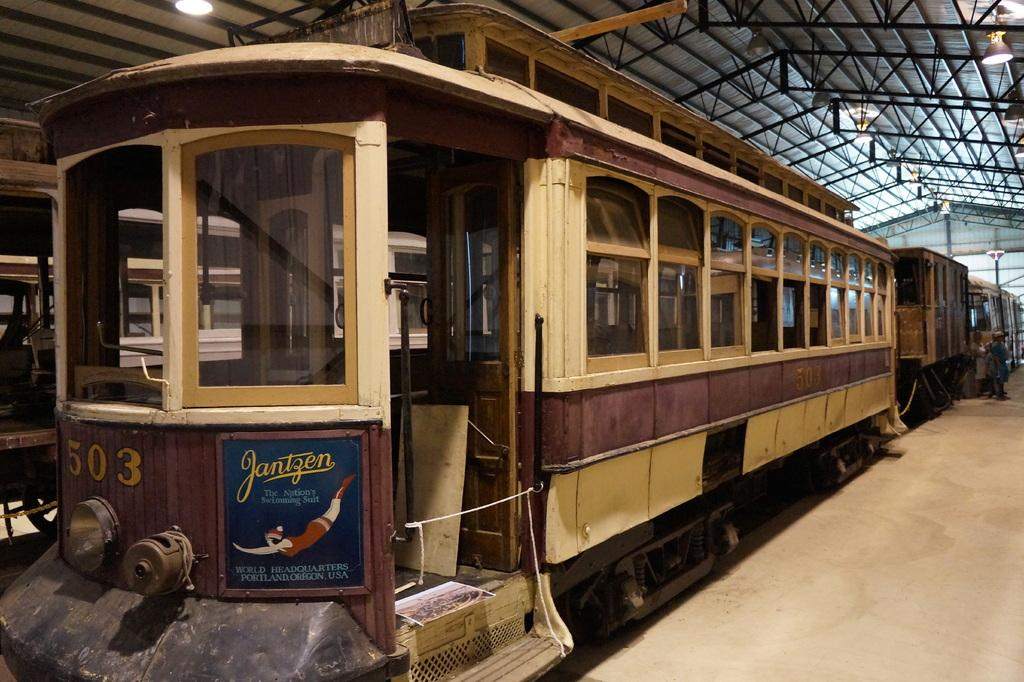What is the main subject of the image? The main subject of the image is a train on the railway track. Where is the train located in relation to the platform? The train is near a platform. Can you describe the background of the image? There is another train in the background, and lights are attached to the roof of the train in the background. What type of religious ceremony is taking place near the train in the image? There is no indication of a religious ceremony taking place in the image; it primarily features trains and a platform. How many pies are visible on the train in the image? There are no pies present in the image; it focuses on trains and their surroundings. 